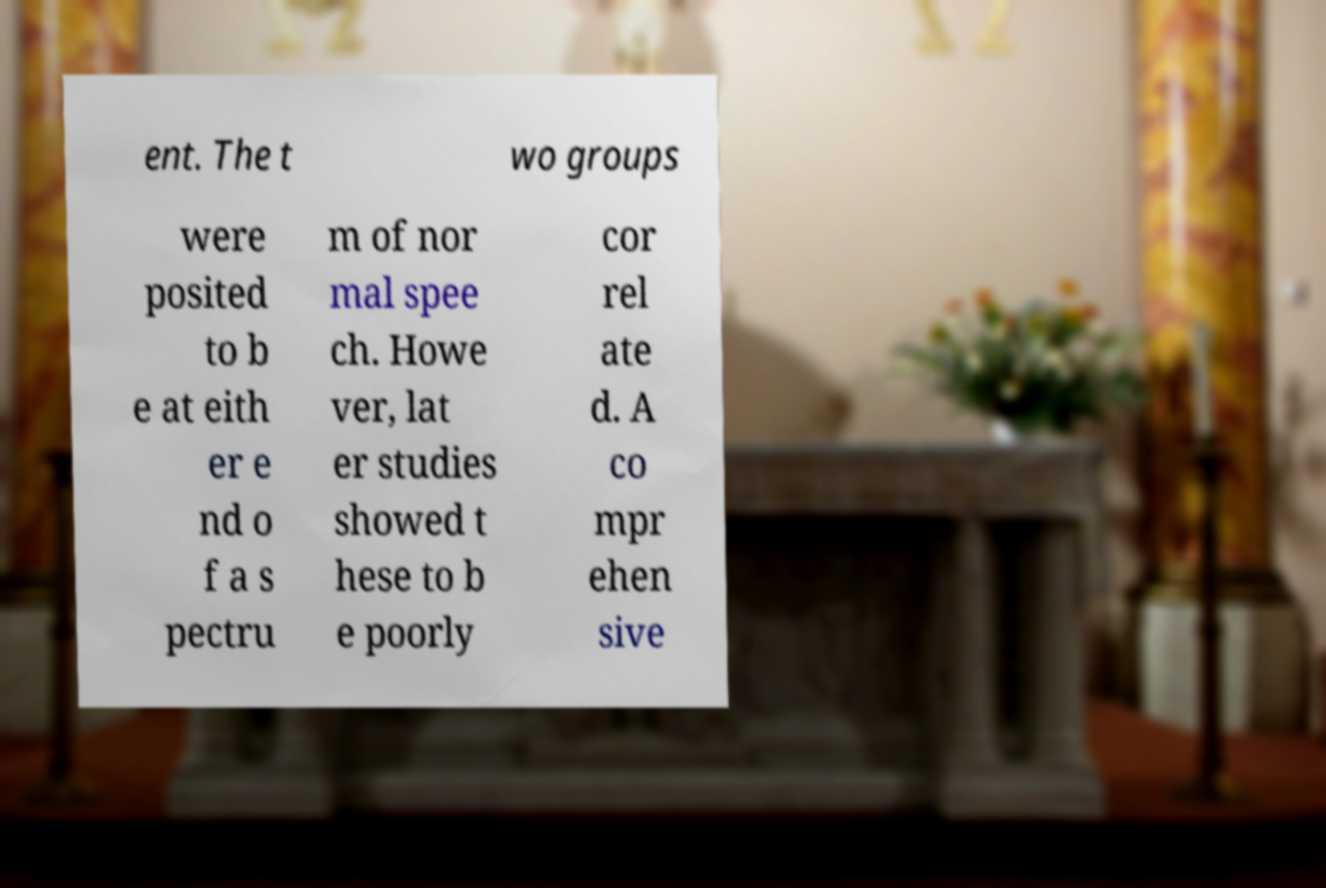For documentation purposes, I need the text within this image transcribed. Could you provide that? ent. The t wo groups were posited to b e at eith er e nd o f a s pectru m of nor mal spee ch. Howe ver, lat er studies showed t hese to b e poorly cor rel ate d. A co mpr ehen sive 